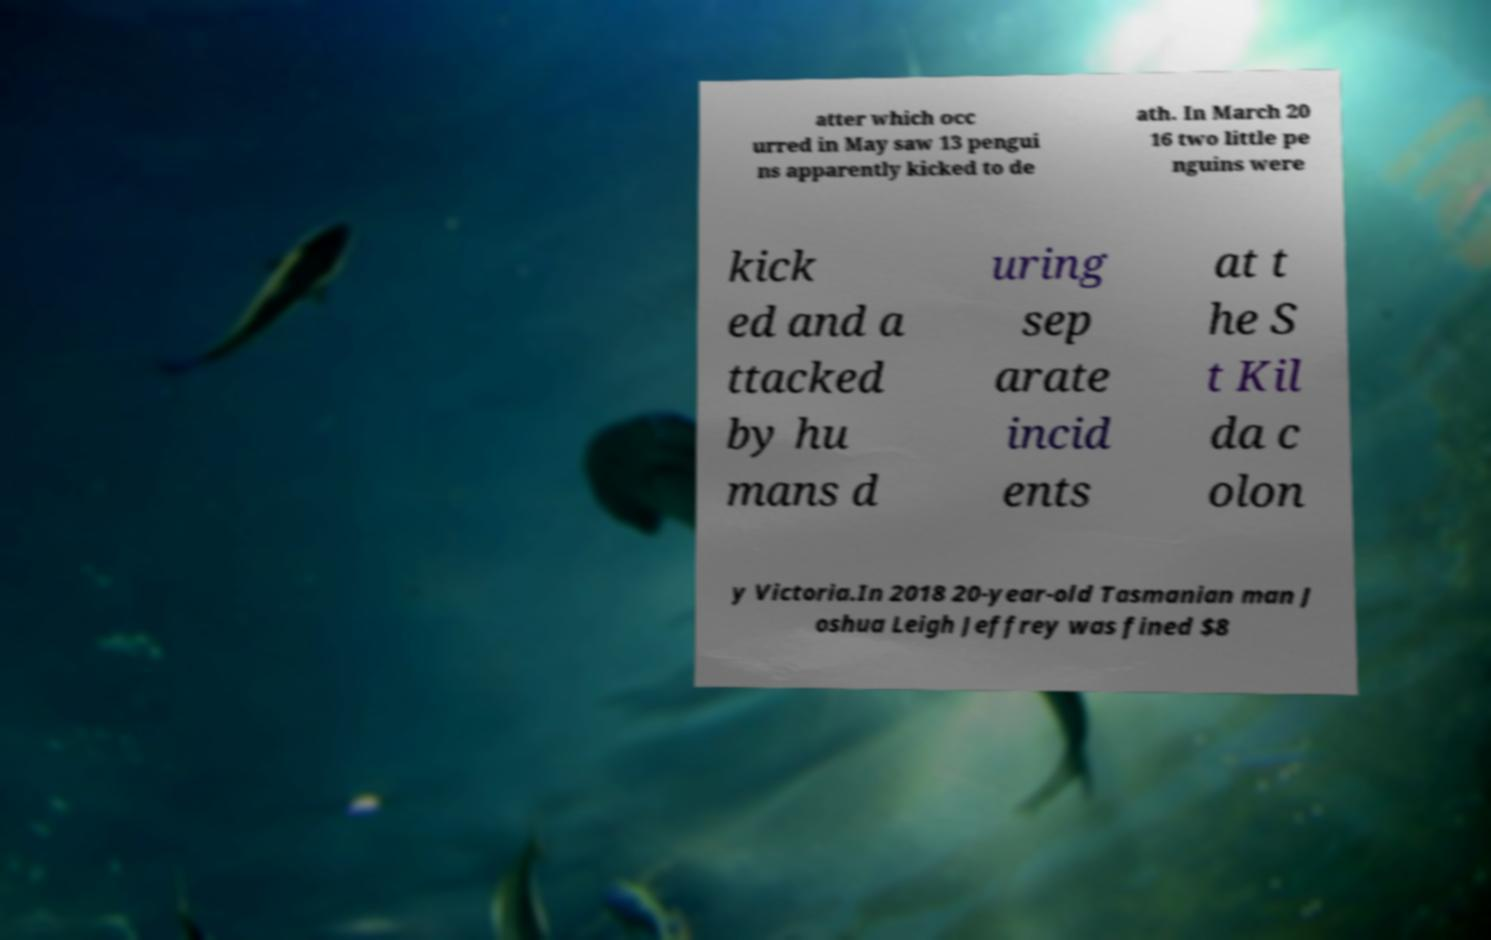Can you accurately transcribe the text from the provided image for me? atter which occ urred in May saw 13 pengui ns apparently kicked to de ath. In March 20 16 two little pe nguins were kick ed and a ttacked by hu mans d uring sep arate incid ents at t he S t Kil da c olon y Victoria.In 2018 20-year-old Tasmanian man J oshua Leigh Jeffrey was fined $8 